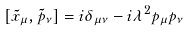Convert formula to latex. <formula><loc_0><loc_0><loc_500><loc_500>[ \tilde { x } _ { \mu } , \tilde { p } _ { \nu } ] = i \delta _ { \mu \nu } - i \lambda ^ { 2 } p _ { \mu } p _ { \nu }</formula> 